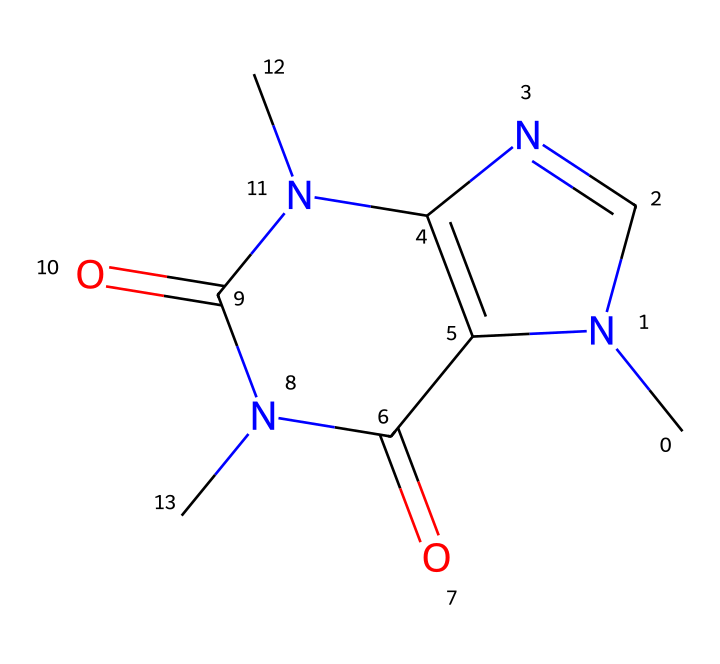What is the chemical name of the compound represented by the SMILES? The SMILES code corresponds to caffeine, a central nervous system stimulant known for its effects on alertness and energy.
Answer: caffeine How many nitrogen atoms are present in this molecule? By examining the structure indicated by the SMILES, there are four nitrogen (N) atoms in the caffeine molecule.
Answer: 4 What is the total number of carbon atoms in the caffeine structure? The SMILES representation shows a total of eight carbon (C) atoms in the molecular structure of caffeine.
Answer: 8 What type of drug is caffeine categorized as? Caffeine is categorized as a stimulant, which means it enhances alertness and can improve focus.
Answer: stimulant Identify a property of caffeine related to advertising creativity. Caffeine enhances cognitive function, leading to increased creativity and focus, which is essential for effective advertising.
Answer: enhances creativity How many rings are present in the caffeine molecule? The structure of caffeine includes two fused rings, which are characteristic of many alkaloids, contributing to its overall structure.
Answer: 2 Which functional groups are present that contribute to caffeine's properties? The presence of carbonyl (C=O) and amine (–NH) groups are significant as they influence caffeine's solubility and biological activity.
Answer: carbonyl and amine 